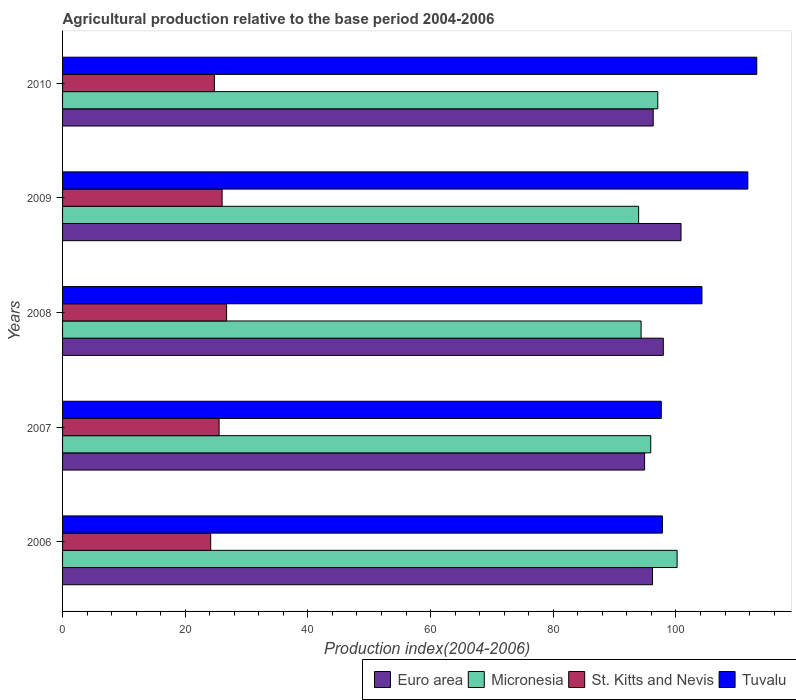How many different coloured bars are there?
Provide a short and direct response. 4. Are the number of bars on each tick of the Y-axis equal?
Make the answer very short. Yes. How many bars are there on the 4th tick from the top?
Give a very brief answer. 4. In how many cases, is the number of bars for a given year not equal to the number of legend labels?
Your response must be concise. 0. What is the agricultural production index in Micronesia in 2009?
Make the answer very short. 93.92. Across all years, what is the maximum agricultural production index in Euro area?
Give a very brief answer. 100.83. Across all years, what is the minimum agricultural production index in Micronesia?
Make the answer very short. 93.92. In which year was the agricultural production index in St. Kitts and Nevis minimum?
Your response must be concise. 2006. What is the total agricultural production index in Tuvalu in the graph?
Offer a very short reply. 524.55. What is the difference between the agricultural production index in Micronesia in 2006 and that in 2009?
Your answer should be compact. 6.27. What is the difference between the agricultural production index in Micronesia in 2006 and the agricultural production index in St. Kitts and Nevis in 2009?
Your answer should be very brief. 74.18. What is the average agricultural production index in St. Kitts and Nevis per year?
Your response must be concise. 25.43. In the year 2008, what is the difference between the agricultural production index in St. Kitts and Nevis and agricultural production index in Euro area?
Give a very brief answer. -71.2. What is the ratio of the agricultural production index in Euro area in 2007 to that in 2010?
Keep it short and to the point. 0.99. Is the agricultural production index in Micronesia in 2007 less than that in 2008?
Your response must be concise. No. Is the difference between the agricultural production index in St. Kitts and Nevis in 2009 and 2010 greater than the difference between the agricultural production index in Euro area in 2009 and 2010?
Provide a short and direct response. No. What is the difference between the highest and the second highest agricultural production index in St. Kitts and Nevis?
Provide a short and direct response. 0.73. What is the difference between the highest and the lowest agricultural production index in St. Kitts and Nevis?
Make the answer very short. 2.59. In how many years, is the agricultural production index in Euro area greater than the average agricultural production index in Euro area taken over all years?
Offer a very short reply. 2. Is the sum of the agricultural production index in Tuvalu in 2008 and 2009 greater than the maximum agricultural production index in St. Kitts and Nevis across all years?
Keep it short and to the point. Yes. What does the 2nd bar from the top in 2006 represents?
Provide a succinct answer. St. Kitts and Nevis. What does the 3rd bar from the bottom in 2006 represents?
Keep it short and to the point. St. Kitts and Nevis. Is it the case that in every year, the sum of the agricultural production index in Tuvalu and agricultural production index in Euro area is greater than the agricultural production index in St. Kitts and Nevis?
Give a very brief answer. Yes. How many bars are there?
Offer a terse response. 20. Are all the bars in the graph horizontal?
Provide a succinct answer. Yes. What is the difference between two consecutive major ticks on the X-axis?
Offer a very short reply. 20. Where does the legend appear in the graph?
Provide a short and direct response. Bottom right. How are the legend labels stacked?
Provide a short and direct response. Horizontal. What is the title of the graph?
Give a very brief answer. Agricultural production relative to the base period 2004-2006. Does "Mali" appear as one of the legend labels in the graph?
Your answer should be very brief. No. What is the label or title of the X-axis?
Your answer should be compact. Production index(2004-2006). What is the label or title of the Y-axis?
Keep it short and to the point. Years. What is the Production index(2004-2006) in Euro area in 2006?
Keep it short and to the point. 96.18. What is the Production index(2004-2006) of Micronesia in 2006?
Ensure brevity in your answer.  100.19. What is the Production index(2004-2006) of St. Kitts and Nevis in 2006?
Offer a terse response. 24.15. What is the Production index(2004-2006) in Tuvalu in 2006?
Your answer should be very brief. 97.8. What is the Production index(2004-2006) of Euro area in 2007?
Ensure brevity in your answer.  94.89. What is the Production index(2004-2006) in Micronesia in 2007?
Keep it short and to the point. 95.89. What is the Production index(2004-2006) of St. Kitts and Nevis in 2007?
Provide a short and direct response. 25.52. What is the Production index(2004-2006) in Tuvalu in 2007?
Your answer should be very brief. 97.61. What is the Production index(2004-2006) in Euro area in 2008?
Give a very brief answer. 97.94. What is the Production index(2004-2006) in Micronesia in 2008?
Provide a short and direct response. 94.32. What is the Production index(2004-2006) in St. Kitts and Nevis in 2008?
Offer a very short reply. 26.74. What is the Production index(2004-2006) of Tuvalu in 2008?
Offer a very short reply. 104.24. What is the Production index(2004-2006) of Euro area in 2009?
Offer a terse response. 100.83. What is the Production index(2004-2006) in Micronesia in 2009?
Make the answer very short. 93.92. What is the Production index(2004-2006) in St. Kitts and Nevis in 2009?
Ensure brevity in your answer.  26.01. What is the Production index(2004-2006) in Tuvalu in 2009?
Ensure brevity in your answer.  111.72. What is the Production index(2004-2006) in Euro area in 2010?
Ensure brevity in your answer.  96.3. What is the Production index(2004-2006) of Micronesia in 2010?
Your answer should be very brief. 97.04. What is the Production index(2004-2006) of St. Kitts and Nevis in 2010?
Your answer should be compact. 24.75. What is the Production index(2004-2006) of Tuvalu in 2010?
Keep it short and to the point. 113.18. Across all years, what is the maximum Production index(2004-2006) of Euro area?
Offer a very short reply. 100.83. Across all years, what is the maximum Production index(2004-2006) in Micronesia?
Keep it short and to the point. 100.19. Across all years, what is the maximum Production index(2004-2006) in St. Kitts and Nevis?
Give a very brief answer. 26.74. Across all years, what is the maximum Production index(2004-2006) of Tuvalu?
Ensure brevity in your answer.  113.18. Across all years, what is the minimum Production index(2004-2006) in Euro area?
Your answer should be compact. 94.89. Across all years, what is the minimum Production index(2004-2006) in Micronesia?
Keep it short and to the point. 93.92. Across all years, what is the minimum Production index(2004-2006) of St. Kitts and Nevis?
Ensure brevity in your answer.  24.15. Across all years, what is the minimum Production index(2004-2006) of Tuvalu?
Give a very brief answer. 97.61. What is the total Production index(2004-2006) in Euro area in the graph?
Give a very brief answer. 486.14. What is the total Production index(2004-2006) of Micronesia in the graph?
Ensure brevity in your answer.  481.36. What is the total Production index(2004-2006) in St. Kitts and Nevis in the graph?
Provide a succinct answer. 127.17. What is the total Production index(2004-2006) of Tuvalu in the graph?
Offer a terse response. 524.55. What is the difference between the Production index(2004-2006) in Euro area in 2006 and that in 2007?
Give a very brief answer. 1.29. What is the difference between the Production index(2004-2006) in St. Kitts and Nevis in 2006 and that in 2007?
Your answer should be compact. -1.37. What is the difference between the Production index(2004-2006) of Tuvalu in 2006 and that in 2007?
Make the answer very short. 0.19. What is the difference between the Production index(2004-2006) in Euro area in 2006 and that in 2008?
Keep it short and to the point. -1.76. What is the difference between the Production index(2004-2006) of Micronesia in 2006 and that in 2008?
Your answer should be very brief. 5.87. What is the difference between the Production index(2004-2006) of St. Kitts and Nevis in 2006 and that in 2008?
Offer a terse response. -2.59. What is the difference between the Production index(2004-2006) in Tuvalu in 2006 and that in 2008?
Make the answer very short. -6.44. What is the difference between the Production index(2004-2006) in Euro area in 2006 and that in 2009?
Provide a short and direct response. -4.65. What is the difference between the Production index(2004-2006) of Micronesia in 2006 and that in 2009?
Make the answer very short. 6.27. What is the difference between the Production index(2004-2006) of St. Kitts and Nevis in 2006 and that in 2009?
Your answer should be very brief. -1.86. What is the difference between the Production index(2004-2006) in Tuvalu in 2006 and that in 2009?
Ensure brevity in your answer.  -13.92. What is the difference between the Production index(2004-2006) in Euro area in 2006 and that in 2010?
Ensure brevity in your answer.  -0.12. What is the difference between the Production index(2004-2006) of Micronesia in 2006 and that in 2010?
Your answer should be very brief. 3.15. What is the difference between the Production index(2004-2006) of St. Kitts and Nevis in 2006 and that in 2010?
Your answer should be compact. -0.6. What is the difference between the Production index(2004-2006) of Tuvalu in 2006 and that in 2010?
Provide a short and direct response. -15.38. What is the difference between the Production index(2004-2006) of Euro area in 2007 and that in 2008?
Offer a very short reply. -3.05. What is the difference between the Production index(2004-2006) in Micronesia in 2007 and that in 2008?
Provide a short and direct response. 1.57. What is the difference between the Production index(2004-2006) of St. Kitts and Nevis in 2007 and that in 2008?
Your response must be concise. -1.22. What is the difference between the Production index(2004-2006) of Tuvalu in 2007 and that in 2008?
Offer a very short reply. -6.63. What is the difference between the Production index(2004-2006) in Euro area in 2007 and that in 2009?
Offer a terse response. -5.94. What is the difference between the Production index(2004-2006) in Micronesia in 2007 and that in 2009?
Your answer should be compact. 1.97. What is the difference between the Production index(2004-2006) of St. Kitts and Nevis in 2007 and that in 2009?
Offer a very short reply. -0.49. What is the difference between the Production index(2004-2006) of Tuvalu in 2007 and that in 2009?
Keep it short and to the point. -14.11. What is the difference between the Production index(2004-2006) of Euro area in 2007 and that in 2010?
Your answer should be very brief. -1.41. What is the difference between the Production index(2004-2006) of Micronesia in 2007 and that in 2010?
Offer a very short reply. -1.15. What is the difference between the Production index(2004-2006) of St. Kitts and Nevis in 2007 and that in 2010?
Offer a very short reply. 0.77. What is the difference between the Production index(2004-2006) of Tuvalu in 2007 and that in 2010?
Your answer should be compact. -15.57. What is the difference between the Production index(2004-2006) of Euro area in 2008 and that in 2009?
Make the answer very short. -2.88. What is the difference between the Production index(2004-2006) of Micronesia in 2008 and that in 2009?
Your answer should be very brief. 0.4. What is the difference between the Production index(2004-2006) in St. Kitts and Nevis in 2008 and that in 2009?
Your response must be concise. 0.73. What is the difference between the Production index(2004-2006) in Tuvalu in 2008 and that in 2009?
Your answer should be very brief. -7.48. What is the difference between the Production index(2004-2006) of Euro area in 2008 and that in 2010?
Your answer should be very brief. 1.65. What is the difference between the Production index(2004-2006) of Micronesia in 2008 and that in 2010?
Offer a terse response. -2.72. What is the difference between the Production index(2004-2006) in St. Kitts and Nevis in 2008 and that in 2010?
Provide a short and direct response. 1.99. What is the difference between the Production index(2004-2006) in Tuvalu in 2008 and that in 2010?
Your answer should be compact. -8.94. What is the difference between the Production index(2004-2006) in Euro area in 2009 and that in 2010?
Provide a succinct answer. 4.53. What is the difference between the Production index(2004-2006) in Micronesia in 2009 and that in 2010?
Your response must be concise. -3.12. What is the difference between the Production index(2004-2006) in St. Kitts and Nevis in 2009 and that in 2010?
Offer a terse response. 1.26. What is the difference between the Production index(2004-2006) of Tuvalu in 2009 and that in 2010?
Keep it short and to the point. -1.46. What is the difference between the Production index(2004-2006) of Euro area in 2006 and the Production index(2004-2006) of Micronesia in 2007?
Your answer should be compact. 0.29. What is the difference between the Production index(2004-2006) of Euro area in 2006 and the Production index(2004-2006) of St. Kitts and Nevis in 2007?
Your response must be concise. 70.66. What is the difference between the Production index(2004-2006) in Euro area in 2006 and the Production index(2004-2006) in Tuvalu in 2007?
Provide a succinct answer. -1.43. What is the difference between the Production index(2004-2006) in Micronesia in 2006 and the Production index(2004-2006) in St. Kitts and Nevis in 2007?
Offer a very short reply. 74.67. What is the difference between the Production index(2004-2006) in Micronesia in 2006 and the Production index(2004-2006) in Tuvalu in 2007?
Give a very brief answer. 2.58. What is the difference between the Production index(2004-2006) in St. Kitts and Nevis in 2006 and the Production index(2004-2006) in Tuvalu in 2007?
Your answer should be compact. -73.46. What is the difference between the Production index(2004-2006) of Euro area in 2006 and the Production index(2004-2006) of Micronesia in 2008?
Ensure brevity in your answer.  1.86. What is the difference between the Production index(2004-2006) in Euro area in 2006 and the Production index(2004-2006) in St. Kitts and Nevis in 2008?
Offer a very short reply. 69.44. What is the difference between the Production index(2004-2006) in Euro area in 2006 and the Production index(2004-2006) in Tuvalu in 2008?
Keep it short and to the point. -8.06. What is the difference between the Production index(2004-2006) of Micronesia in 2006 and the Production index(2004-2006) of St. Kitts and Nevis in 2008?
Provide a succinct answer. 73.45. What is the difference between the Production index(2004-2006) of Micronesia in 2006 and the Production index(2004-2006) of Tuvalu in 2008?
Provide a succinct answer. -4.05. What is the difference between the Production index(2004-2006) in St. Kitts and Nevis in 2006 and the Production index(2004-2006) in Tuvalu in 2008?
Ensure brevity in your answer.  -80.09. What is the difference between the Production index(2004-2006) of Euro area in 2006 and the Production index(2004-2006) of Micronesia in 2009?
Keep it short and to the point. 2.26. What is the difference between the Production index(2004-2006) of Euro area in 2006 and the Production index(2004-2006) of St. Kitts and Nevis in 2009?
Your answer should be very brief. 70.17. What is the difference between the Production index(2004-2006) of Euro area in 2006 and the Production index(2004-2006) of Tuvalu in 2009?
Your answer should be compact. -15.54. What is the difference between the Production index(2004-2006) of Micronesia in 2006 and the Production index(2004-2006) of St. Kitts and Nevis in 2009?
Offer a very short reply. 74.18. What is the difference between the Production index(2004-2006) in Micronesia in 2006 and the Production index(2004-2006) in Tuvalu in 2009?
Offer a very short reply. -11.53. What is the difference between the Production index(2004-2006) in St. Kitts and Nevis in 2006 and the Production index(2004-2006) in Tuvalu in 2009?
Ensure brevity in your answer.  -87.57. What is the difference between the Production index(2004-2006) in Euro area in 2006 and the Production index(2004-2006) in Micronesia in 2010?
Give a very brief answer. -0.86. What is the difference between the Production index(2004-2006) in Euro area in 2006 and the Production index(2004-2006) in St. Kitts and Nevis in 2010?
Offer a very short reply. 71.43. What is the difference between the Production index(2004-2006) of Euro area in 2006 and the Production index(2004-2006) of Tuvalu in 2010?
Ensure brevity in your answer.  -17. What is the difference between the Production index(2004-2006) of Micronesia in 2006 and the Production index(2004-2006) of St. Kitts and Nevis in 2010?
Keep it short and to the point. 75.44. What is the difference between the Production index(2004-2006) in Micronesia in 2006 and the Production index(2004-2006) in Tuvalu in 2010?
Keep it short and to the point. -12.99. What is the difference between the Production index(2004-2006) of St. Kitts and Nevis in 2006 and the Production index(2004-2006) of Tuvalu in 2010?
Your answer should be very brief. -89.03. What is the difference between the Production index(2004-2006) of Euro area in 2007 and the Production index(2004-2006) of Micronesia in 2008?
Offer a terse response. 0.57. What is the difference between the Production index(2004-2006) in Euro area in 2007 and the Production index(2004-2006) in St. Kitts and Nevis in 2008?
Keep it short and to the point. 68.15. What is the difference between the Production index(2004-2006) of Euro area in 2007 and the Production index(2004-2006) of Tuvalu in 2008?
Provide a succinct answer. -9.35. What is the difference between the Production index(2004-2006) of Micronesia in 2007 and the Production index(2004-2006) of St. Kitts and Nevis in 2008?
Your answer should be compact. 69.15. What is the difference between the Production index(2004-2006) in Micronesia in 2007 and the Production index(2004-2006) in Tuvalu in 2008?
Provide a succinct answer. -8.35. What is the difference between the Production index(2004-2006) of St. Kitts and Nevis in 2007 and the Production index(2004-2006) of Tuvalu in 2008?
Provide a succinct answer. -78.72. What is the difference between the Production index(2004-2006) of Euro area in 2007 and the Production index(2004-2006) of Micronesia in 2009?
Make the answer very short. 0.97. What is the difference between the Production index(2004-2006) of Euro area in 2007 and the Production index(2004-2006) of St. Kitts and Nevis in 2009?
Offer a very short reply. 68.88. What is the difference between the Production index(2004-2006) of Euro area in 2007 and the Production index(2004-2006) of Tuvalu in 2009?
Keep it short and to the point. -16.83. What is the difference between the Production index(2004-2006) in Micronesia in 2007 and the Production index(2004-2006) in St. Kitts and Nevis in 2009?
Keep it short and to the point. 69.88. What is the difference between the Production index(2004-2006) in Micronesia in 2007 and the Production index(2004-2006) in Tuvalu in 2009?
Provide a short and direct response. -15.83. What is the difference between the Production index(2004-2006) of St. Kitts and Nevis in 2007 and the Production index(2004-2006) of Tuvalu in 2009?
Your response must be concise. -86.2. What is the difference between the Production index(2004-2006) of Euro area in 2007 and the Production index(2004-2006) of Micronesia in 2010?
Give a very brief answer. -2.15. What is the difference between the Production index(2004-2006) in Euro area in 2007 and the Production index(2004-2006) in St. Kitts and Nevis in 2010?
Your response must be concise. 70.14. What is the difference between the Production index(2004-2006) of Euro area in 2007 and the Production index(2004-2006) of Tuvalu in 2010?
Offer a very short reply. -18.29. What is the difference between the Production index(2004-2006) of Micronesia in 2007 and the Production index(2004-2006) of St. Kitts and Nevis in 2010?
Offer a very short reply. 71.14. What is the difference between the Production index(2004-2006) of Micronesia in 2007 and the Production index(2004-2006) of Tuvalu in 2010?
Give a very brief answer. -17.29. What is the difference between the Production index(2004-2006) of St. Kitts and Nevis in 2007 and the Production index(2004-2006) of Tuvalu in 2010?
Offer a terse response. -87.66. What is the difference between the Production index(2004-2006) in Euro area in 2008 and the Production index(2004-2006) in Micronesia in 2009?
Your answer should be compact. 4.02. What is the difference between the Production index(2004-2006) of Euro area in 2008 and the Production index(2004-2006) of St. Kitts and Nevis in 2009?
Offer a very short reply. 71.93. What is the difference between the Production index(2004-2006) in Euro area in 2008 and the Production index(2004-2006) in Tuvalu in 2009?
Your response must be concise. -13.78. What is the difference between the Production index(2004-2006) of Micronesia in 2008 and the Production index(2004-2006) of St. Kitts and Nevis in 2009?
Ensure brevity in your answer.  68.31. What is the difference between the Production index(2004-2006) of Micronesia in 2008 and the Production index(2004-2006) of Tuvalu in 2009?
Your answer should be compact. -17.4. What is the difference between the Production index(2004-2006) in St. Kitts and Nevis in 2008 and the Production index(2004-2006) in Tuvalu in 2009?
Ensure brevity in your answer.  -84.98. What is the difference between the Production index(2004-2006) in Euro area in 2008 and the Production index(2004-2006) in Micronesia in 2010?
Give a very brief answer. 0.9. What is the difference between the Production index(2004-2006) of Euro area in 2008 and the Production index(2004-2006) of St. Kitts and Nevis in 2010?
Make the answer very short. 73.19. What is the difference between the Production index(2004-2006) in Euro area in 2008 and the Production index(2004-2006) in Tuvalu in 2010?
Provide a succinct answer. -15.24. What is the difference between the Production index(2004-2006) in Micronesia in 2008 and the Production index(2004-2006) in St. Kitts and Nevis in 2010?
Give a very brief answer. 69.57. What is the difference between the Production index(2004-2006) of Micronesia in 2008 and the Production index(2004-2006) of Tuvalu in 2010?
Offer a terse response. -18.86. What is the difference between the Production index(2004-2006) of St. Kitts and Nevis in 2008 and the Production index(2004-2006) of Tuvalu in 2010?
Ensure brevity in your answer.  -86.44. What is the difference between the Production index(2004-2006) in Euro area in 2009 and the Production index(2004-2006) in Micronesia in 2010?
Your answer should be very brief. 3.79. What is the difference between the Production index(2004-2006) in Euro area in 2009 and the Production index(2004-2006) in St. Kitts and Nevis in 2010?
Provide a succinct answer. 76.08. What is the difference between the Production index(2004-2006) of Euro area in 2009 and the Production index(2004-2006) of Tuvalu in 2010?
Keep it short and to the point. -12.35. What is the difference between the Production index(2004-2006) in Micronesia in 2009 and the Production index(2004-2006) in St. Kitts and Nevis in 2010?
Give a very brief answer. 69.17. What is the difference between the Production index(2004-2006) in Micronesia in 2009 and the Production index(2004-2006) in Tuvalu in 2010?
Offer a terse response. -19.26. What is the difference between the Production index(2004-2006) of St. Kitts and Nevis in 2009 and the Production index(2004-2006) of Tuvalu in 2010?
Provide a short and direct response. -87.17. What is the average Production index(2004-2006) in Euro area per year?
Provide a succinct answer. 97.23. What is the average Production index(2004-2006) in Micronesia per year?
Make the answer very short. 96.27. What is the average Production index(2004-2006) in St. Kitts and Nevis per year?
Give a very brief answer. 25.43. What is the average Production index(2004-2006) in Tuvalu per year?
Make the answer very short. 104.91. In the year 2006, what is the difference between the Production index(2004-2006) of Euro area and Production index(2004-2006) of Micronesia?
Keep it short and to the point. -4.01. In the year 2006, what is the difference between the Production index(2004-2006) in Euro area and Production index(2004-2006) in St. Kitts and Nevis?
Your answer should be compact. 72.03. In the year 2006, what is the difference between the Production index(2004-2006) in Euro area and Production index(2004-2006) in Tuvalu?
Your answer should be compact. -1.62. In the year 2006, what is the difference between the Production index(2004-2006) of Micronesia and Production index(2004-2006) of St. Kitts and Nevis?
Make the answer very short. 76.04. In the year 2006, what is the difference between the Production index(2004-2006) of Micronesia and Production index(2004-2006) of Tuvalu?
Your answer should be compact. 2.39. In the year 2006, what is the difference between the Production index(2004-2006) of St. Kitts and Nevis and Production index(2004-2006) of Tuvalu?
Offer a very short reply. -73.65. In the year 2007, what is the difference between the Production index(2004-2006) of Euro area and Production index(2004-2006) of Micronesia?
Make the answer very short. -1. In the year 2007, what is the difference between the Production index(2004-2006) in Euro area and Production index(2004-2006) in St. Kitts and Nevis?
Your response must be concise. 69.37. In the year 2007, what is the difference between the Production index(2004-2006) in Euro area and Production index(2004-2006) in Tuvalu?
Your answer should be compact. -2.72. In the year 2007, what is the difference between the Production index(2004-2006) in Micronesia and Production index(2004-2006) in St. Kitts and Nevis?
Provide a succinct answer. 70.37. In the year 2007, what is the difference between the Production index(2004-2006) in Micronesia and Production index(2004-2006) in Tuvalu?
Offer a very short reply. -1.72. In the year 2007, what is the difference between the Production index(2004-2006) in St. Kitts and Nevis and Production index(2004-2006) in Tuvalu?
Provide a short and direct response. -72.09. In the year 2008, what is the difference between the Production index(2004-2006) of Euro area and Production index(2004-2006) of Micronesia?
Your answer should be compact. 3.62. In the year 2008, what is the difference between the Production index(2004-2006) of Euro area and Production index(2004-2006) of St. Kitts and Nevis?
Offer a terse response. 71.2. In the year 2008, what is the difference between the Production index(2004-2006) in Euro area and Production index(2004-2006) in Tuvalu?
Your response must be concise. -6.3. In the year 2008, what is the difference between the Production index(2004-2006) of Micronesia and Production index(2004-2006) of St. Kitts and Nevis?
Make the answer very short. 67.58. In the year 2008, what is the difference between the Production index(2004-2006) of Micronesia and Production index(2004-2006) of Tuvalu?
Provide a short and direct response. -9.92. In the year 2008, what is the difference between the Production index(2004-2006) of St. Kitts and Nevis and Production index(2004-2006) of Tuvalu?
Offer a terse response. -77.5. In the year 2009, what is the difference between the Production index(2004-2006) of Euro area and Production index(2004-2006) of Micronesia?
Make the answer very short. 6.91. In the year 2009, what is the difference between the Production index(2004-2006) of Euro area and Production index(2004-2006) of St. Kitts and Nevis?
Your answer should be compact. 74.82. In the year 2009, what is the difference between the Production index(2004-2006) of Euro area and Production index(2004-2006) of Tuvalu?
Give a very brief answer. -10.89. In the year 2009, what is the difference between the Production index(2004-2006) of Micronesia and Production index(2004-2006) of St. Kitts and Nevis?
Provide a succinct answer. 67.91. In the year 2009, what is the difference between the Production index(2004-2006) of Micronesia and Production index(2004-2006) of Tuvalu?
Offer a terse response. -17.8. In the year 2009, what is the difference between the Production index(2004-2006) of St. Kitts and Nevis and Production index(2004-2006) of Tuvalu?
Provide a short and direct response. -85.71. In the year 2010, what is the difference between the Production index(2004-2006) in Euro area and Production index(2004-2006) in Micronesia?
Your response must be concise. -0.74. In the year 2010, what is the difference between the Production index(2004-2006) of Euro area and Production index(2004-2006) of St. Kitts and Nevis?
Provide a short and direct response. 71.55. In the year 2010, what is the difference between the Production index(2004-2006) of Euro area and Production index(2004-2006) of Tuvalu?
Your response must be concise. -16.88. In the year 2010, what is the difference between the Production index(2004-2006) in Micronesia and Production index(2004-2006) in St. Kitts and Nevis?
Your answer should be compact. 72.29. In the year 2010, what is the difference between the Production index(2004-2006) in Micronesia and Production index(2004-2006) in Tuvalu?
Your answer should be very brief. -16.14. In the year 2010, what is the difference between the Production index(2004-2006) in St. Kitts and Nevis and Production index(2004-2006) in Tuvalu?
Your answer should be compact. -88.43. What is the ratio of the Production index(2004-2006) in Euro area in 2006 to that in 2007?
Offer a terse response. 1.01. What is the ratio of the Production index(2004-2006) in Micronesia in 2006 to that in 2007?
Ensure brevity in your answer.  1.04. What is the ratio of the Production index(2004-2006) in St. Kitts and Nevis in 2006 to that in 2007?
Your answer should be very brief. 0.95. What is the ratio of the Production index(2004-2006) in Euro area in 2006 to that in 2008?
Offer a terse response. 0.98. What is the ratio of the Production index(2004-2006) of Micronesia in 2006 to that in 2008?
Your answer should be compact. 1.06. What is the ratio of the Production index(2004-2006) of St. Kitts and Nevis in 2006 to that in 2008?
Ensure brevity in your answer.  0.9. What is the ratio of the Production index(2004-2006) of Tuvalu in 2006 to that in 2008?
Offer a very short reply. 0.94. What is the ratio of the Production index(2004-2006) of Euro area in 2006 to that in 2009?
Provide a succinct answer. 0.95. What is the ratio of the Production index(2004-2006) in Micronesia in 2006 to that in 2009?
Keep it short and to the point. 1.07. What is the ratio of the Production index(2004-2006) in St. Kitts and Nevis in 2006 to that in 2009?
Your answer should be compact. 0.93. What is the ratio of the Production index(2004-2006) in Tuvalu in 2006 to that in 2009?
Keep it short and to the point. 0.88. What is the ratio of the Production index(2004-2006) in Euro area in 2006 to that in 2010?
Provide a succinct answer. 1. What is the ratio of the Production index(2004-2006) of Micronesia in 2006 to that in 2010?
Your response must be concise. 1.03. What is the ratio of the Production index(2004-2006) in St. Kitts and Nevis in 2006 to that in 2010?
Ensure brevity in your answer.  0.98. What is the ratio of the Production index(2004-2006) of Tuvalu in 2006 to that in 2010?
Keep it short and to the point. 0.86. What is the ratio of the Production index(2004-2006) in Euro area in 2007 to that in 2008?
Offer a very short reply. 0.97. What is the ratio of the Production index(2004-2006) in Micronesia in 2007 to that in 2008?
Keep it short and to the point. 1.02. What is the ratio of the Production index(2004-2006) in St. Kitts and Nevis in 2007 to that in 2008?
Give a very brief answer. 0.95. What is the ratio of the Production index(2004-2006) in Tuvalu in 2007 to that in 2008?
Ensure brevity in your answer.  0.94. What is the ratio of the Production index(2004-2006) of Euro area in 2007 to that in 2009?
Your answer should be very brief. 0.94. What is the ratio of the Production index(2004-2006) of Micronesia in 2007 to that in 2009?
Make the answer very short. 1.02. What is the ratio of the Production index(2004-2006) of St. Kitts and Nevis in 2007 to that in 2009?
Provide a short and direct response. 0.98. What is the ratio of the Production index(2004-2006) of Tuvalu in 2007 to that in 2009?
Provide a succinct answer. 0.87. What is the ratio of the Production index(2004-2006) in Euro area in 2007 to that in 2010?
Provide a short and direct response. 0.99. What is the ratio of the Production index(2004-2006) in Micronesia in 2007 to that in 2010?
Offer a very short reply. 0.99. What is the ratio of the Production index(2004-2006) of St. Kitts and Nevis in 2007 to that in 2010?
Your response must be concise. 1.03. What is the ratio of the Production index(2004-2006) in Tuvalu in 2007 to that in 2010?
Offer a very short reply. 0.86. What is the ratio of the Production index(2004-2006) in Euro area in 2008 to that in 2009?
Ensure brevity in your answer.  0.97. What is the ratio of the Production index(2004-2006) of Micronesia in 2008 to that in 2009?
Offer a terse response. 1. What is the ratio of the Production index(2004-2006) of St. Kitts and Nevis in 2008 to that in 2009?
Keep it short and to the point. 1.03. What is the ratio of the Production index(2004-2006) of Tuvalu in 2008 to that in 2009?
Offer a very short reply. 0.93. What is the ratio of the Production index(2004-2006) of Euro area in 2008 to that in 2010?
Your answer should be compact. 1.02. What is the ratio of the Production index(2004-2006) in Micronesia in 2008 to that in 2010?
Offer a very short reply. 0.97. What is the ratio of the Production index(2004-2006) in St. Kitts and Nevis in 2008 to that in 2010?
Ensure brevity in your answer.  1.08. What is the ratio of the Production index(2004-2006) of Tuvalu in 2008 to that in 2010?
Your answer should be compact. 0.92. What is the ratio of the Production index(2004-2006) in Euro area in 2009 to that in 2010?
Your answer should be very brief. 1.05. What is the ratio of the Production index(2004-2006) in Micronesia in 2009 to that in 2010?
Offer a terse response. 0.97. What is the ratio of the Production index(2004-2006) in St. Kitts and Nevis in 2009 to that in 2010?
Your answer should be very brief. 1.05. What is the ratio of the Production index(2004-2006) in Tuvalu in 2009 to that in 2010?
Make the answer very short. 0.99. What is the difference between the highest and the second highest Production index(2004-2006) in Euro area?
Offer a terse response. 2.88. What is the difference between the highest and the second highest Production index(2004-2006) in Micronesia?
Provide a short and direct response. 3.15. What is the difference between the highest and the second highest Production index(2004-2006) of St. Kitts and Nevis?
Provide a short and direct response. 0.73. What is the difference between the highest and the second highest Production index(2004-2006) of Tuvalu?
Make the answer very short. 1.46. What is the difference between the highest and the lowest Production index(2004-2006) of Euro area?
Give a very brief answer. 5.94. What is the difference between the highest and the lowest Production index(2004-2006) in Micronesia?
Offer a very short reply. 6.27. What is the difference between the highest and the lowest Production index(2004-2006) of St. Kitts and Nevis?
Ensure brevity in your answer.  2.59. What is the difference between the highest and the lowest Production index(2004-2006) of Tuvalu?
Provide a short and direct response. 15.57. 